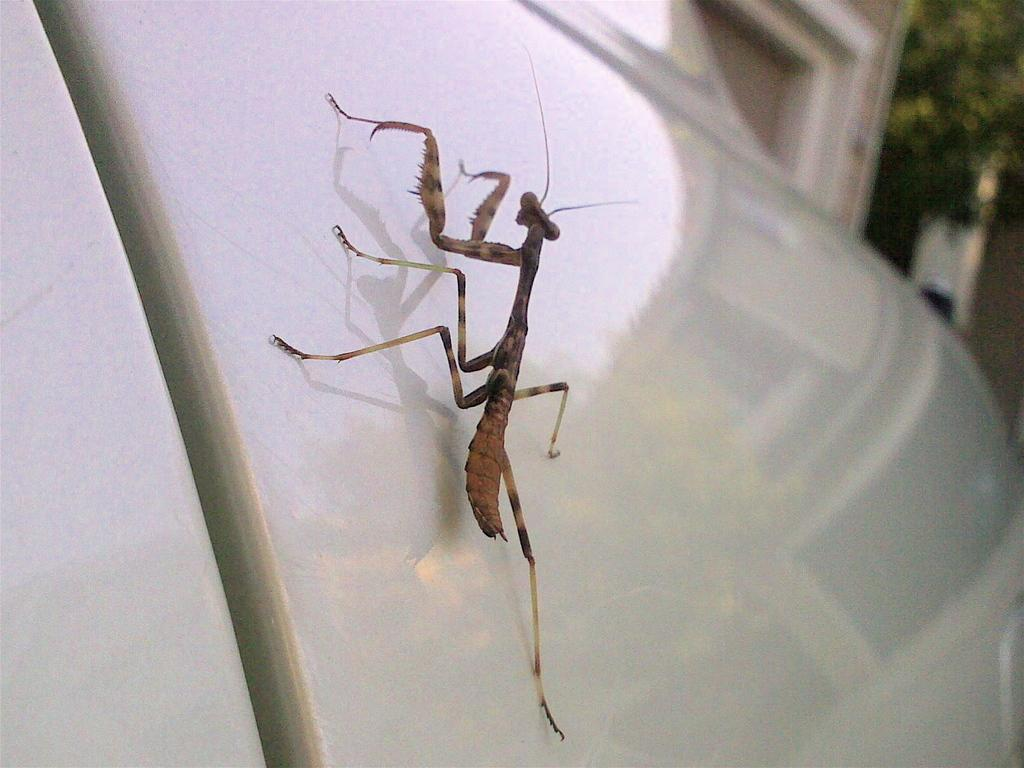What type of animal is in the image? There is a grasshopper in the image. Where is the grasshopper located? The grasshopper is standing on a vehicle. What other object can be seen in the image besides the grasshopper and vehicle? There is a plant in the image. What is the background of the plant in the image? The plant is in front of a wall. How many passengers are in the vehicle with the grasshopper? There is no information about passengers in the image; it only shows a grasshopper standing on a vehicle. 